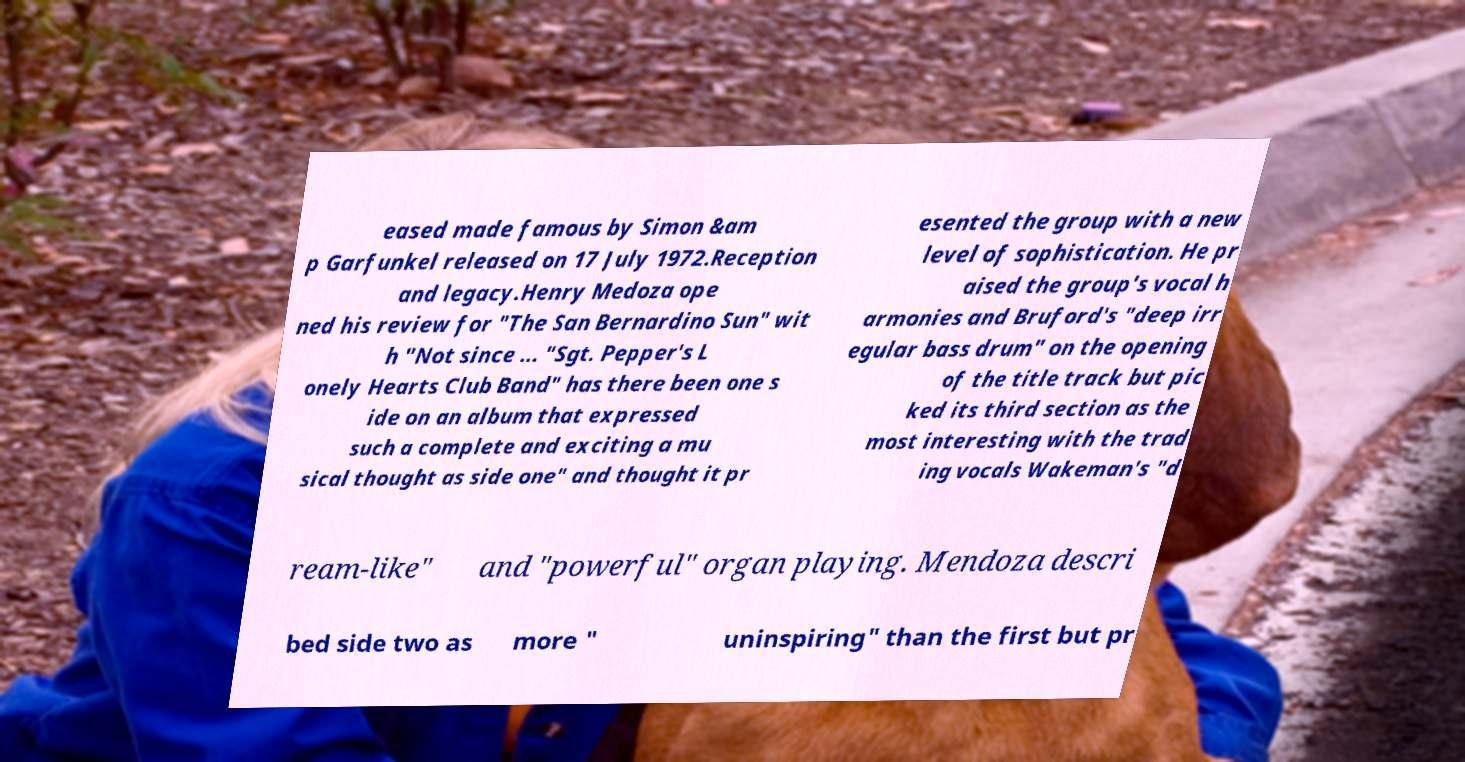Could you assist in decoding the text presented in this image and type it out clearly? eased made famous by Simon &am p Garfunkel released on 17 July 1972.Reception and legacy.Henry Medoza ope ned his review for "The San Bernardino Sun" wit h "Not since ... "Sgt. Pepper's L onely Hearts Club Band" has there been one s ide on an album that expressed such a complete and exciting a mu sical thought as side one" and thought it pr esented the group with a new level of sophistication. He pr aised the group's vocal h armonies and Bruford's "deep irr egular bass drum" on the opening of the title track but pic ked its third section as the most interesting with the trad ing vocals Wakeman's "d ream-like" and "powerful" organ playing. Mendoza descri bed side two as more " uninspiring" than the first but pr 